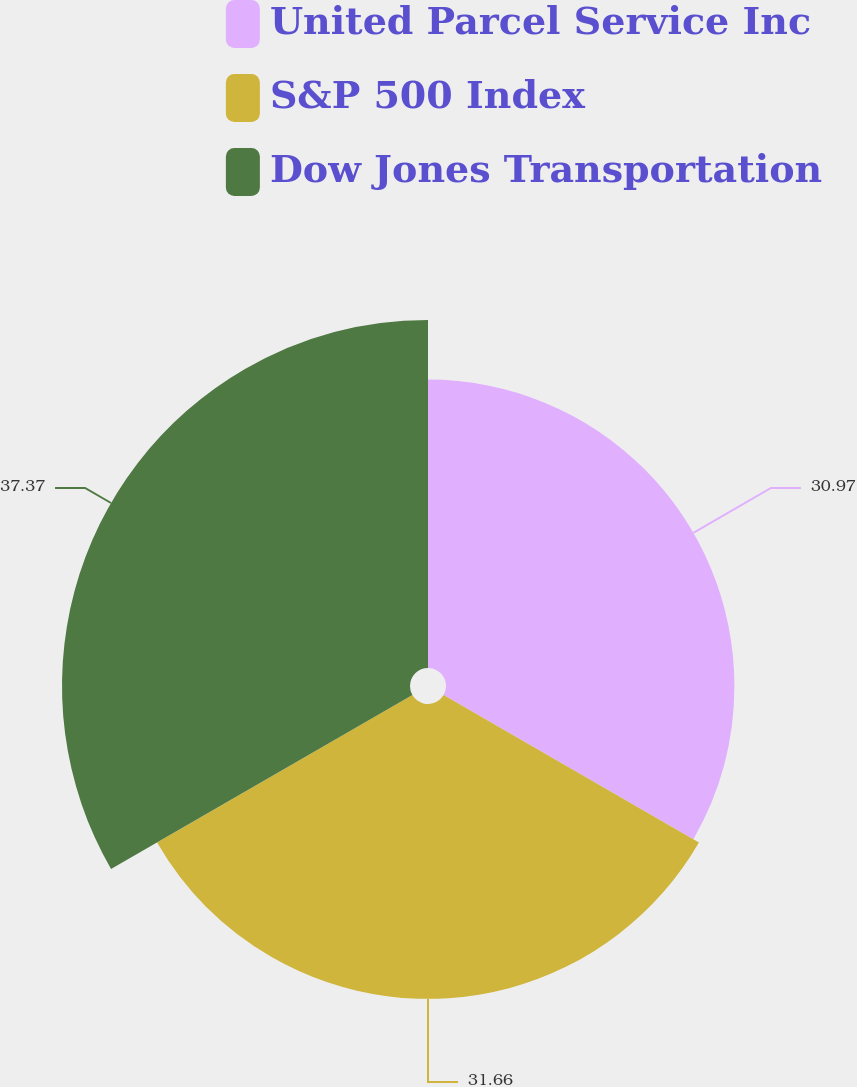<chart> <loc_0><loc_0><loc_500><loc_500><pie_chart><fcel>United Parcel Service Inc<fcel>S&P 500 Index<fcel>Dow Jones Transportation<nl><fcel>30.97%<fcel>31.66%<fcel>37.37%<nl></chart> 